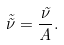Convert formula to latex. <formula><loc_0><loc_0><loc_500><loc_500>\tilde { \tilde { \nu } } = \frac { \tilde { \nu } } { A } .</formula> 